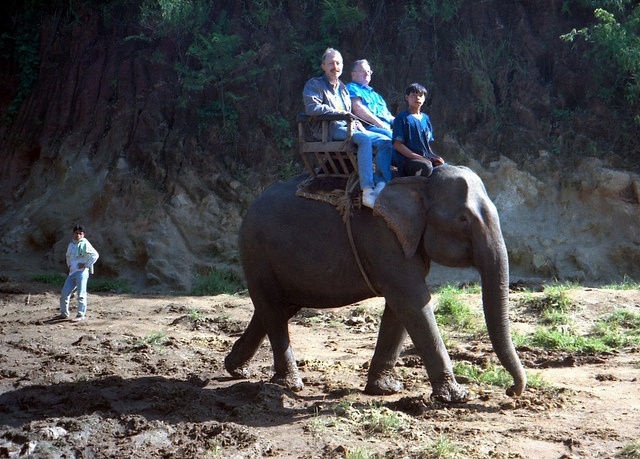Describe the objects in this image and their specific colors. I can see elephant in black, gray, lightgray, and darkgray tones, people in black, blue, navy, white, and gray tones, people in black, navy, gray, and maroon tones, people in black, white, cyan, lightblue, and darkgray tones, and people in black, gray, and white tones in this image. 